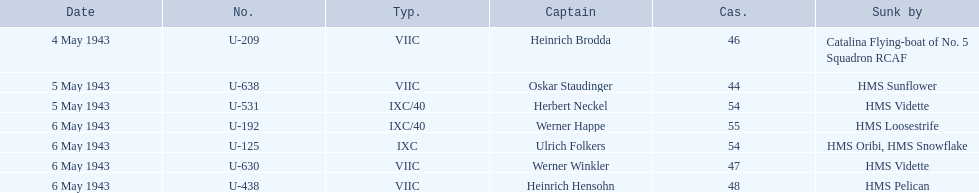Would you mind parsing the complete table? {'header': ['Date', 'No.', 'Typ.', 'Captain', 'Cas.', 'Sunk by'], 'rows': [['4 May 1943', 'U-209', 'VIIC', 'Heinrich Brodda', '46', 'Catalina Flying-boat of No. 5 Squadron RCAF'], ['5 May 1943', 'U-638', 'VIIC', 'Oskar Staudinger', '44', 'HMS Sunflower'], ['5 May 1943', 'U-531', 'IXC/40', 'Herbert Neckel', '54', 'HMS Vidette'], ['6 May 1943', 'U-192', 'IXC/40', 'Werner Happe', '55', 'HMS Loosestrife'], ['6 May 1943', 'U-125', 'IXC', 'Ulrich Folkers', '54', 'HMS Oribi, HMS Snowflake'], ['6 May 1943', 'U-630', 'VIIC', 'Werner Winkler', '47', 'HMS Vidette'], ['6 May 1943', 'U-438', 'VIIC', 'Heinrich Hensohn', '48', 'HMS Pelican']]} What was the only captain sunk by hms pelican? Heinrich Hensohn. 